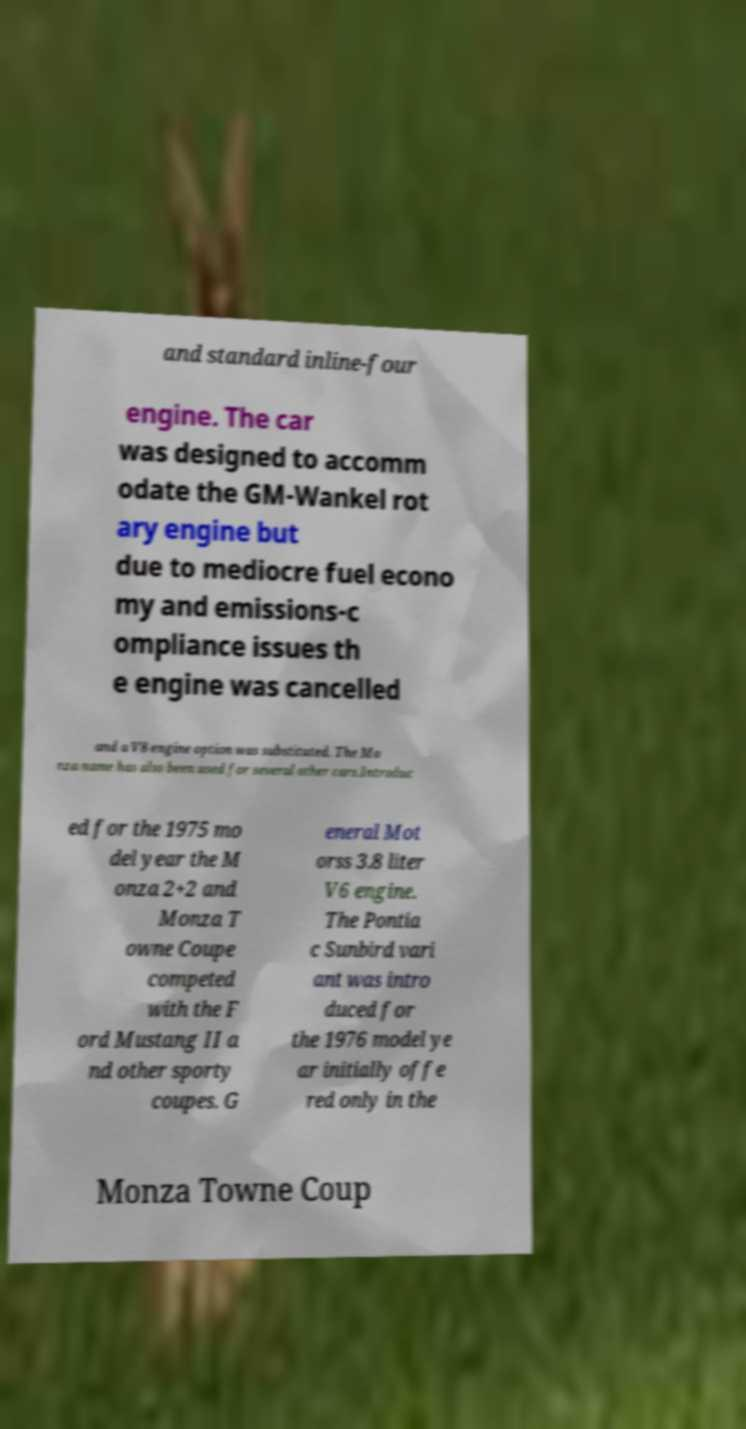Could you extract and type out the text from this image? and standard inline-four engine. The car was designed to accomm odate the GM-Wankel rot ary engine but due to mediocre fuel econo my and emissions-c ompliance issues th e engine was cancelled and a V8 engine option was substituted. The Mo nza name has also been used for several other cars.Introduc ed for the 1975 mo del year the M onza 2+2 and Monza T owne Coupe competed with the F ord Mustang II a nd other sporty coupes. G eneral Mot orss 3.8 liter V6 engine. The Pontia c Sunbird vari ant was intro duced for the 1976 model ye ar initially offe red only in the Monza Towne Coup 